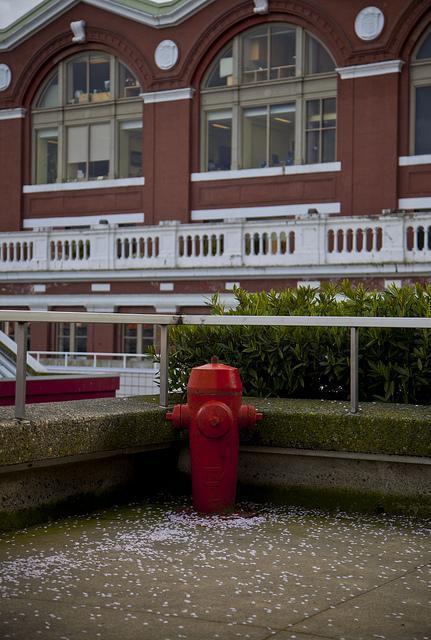How many people are wearing yellow jacket?
Give a very brief answer. 0. 